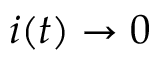<formula> <loc_0><loc_0><loc_500><loc_500>i ( t ) \to 0</formula> 